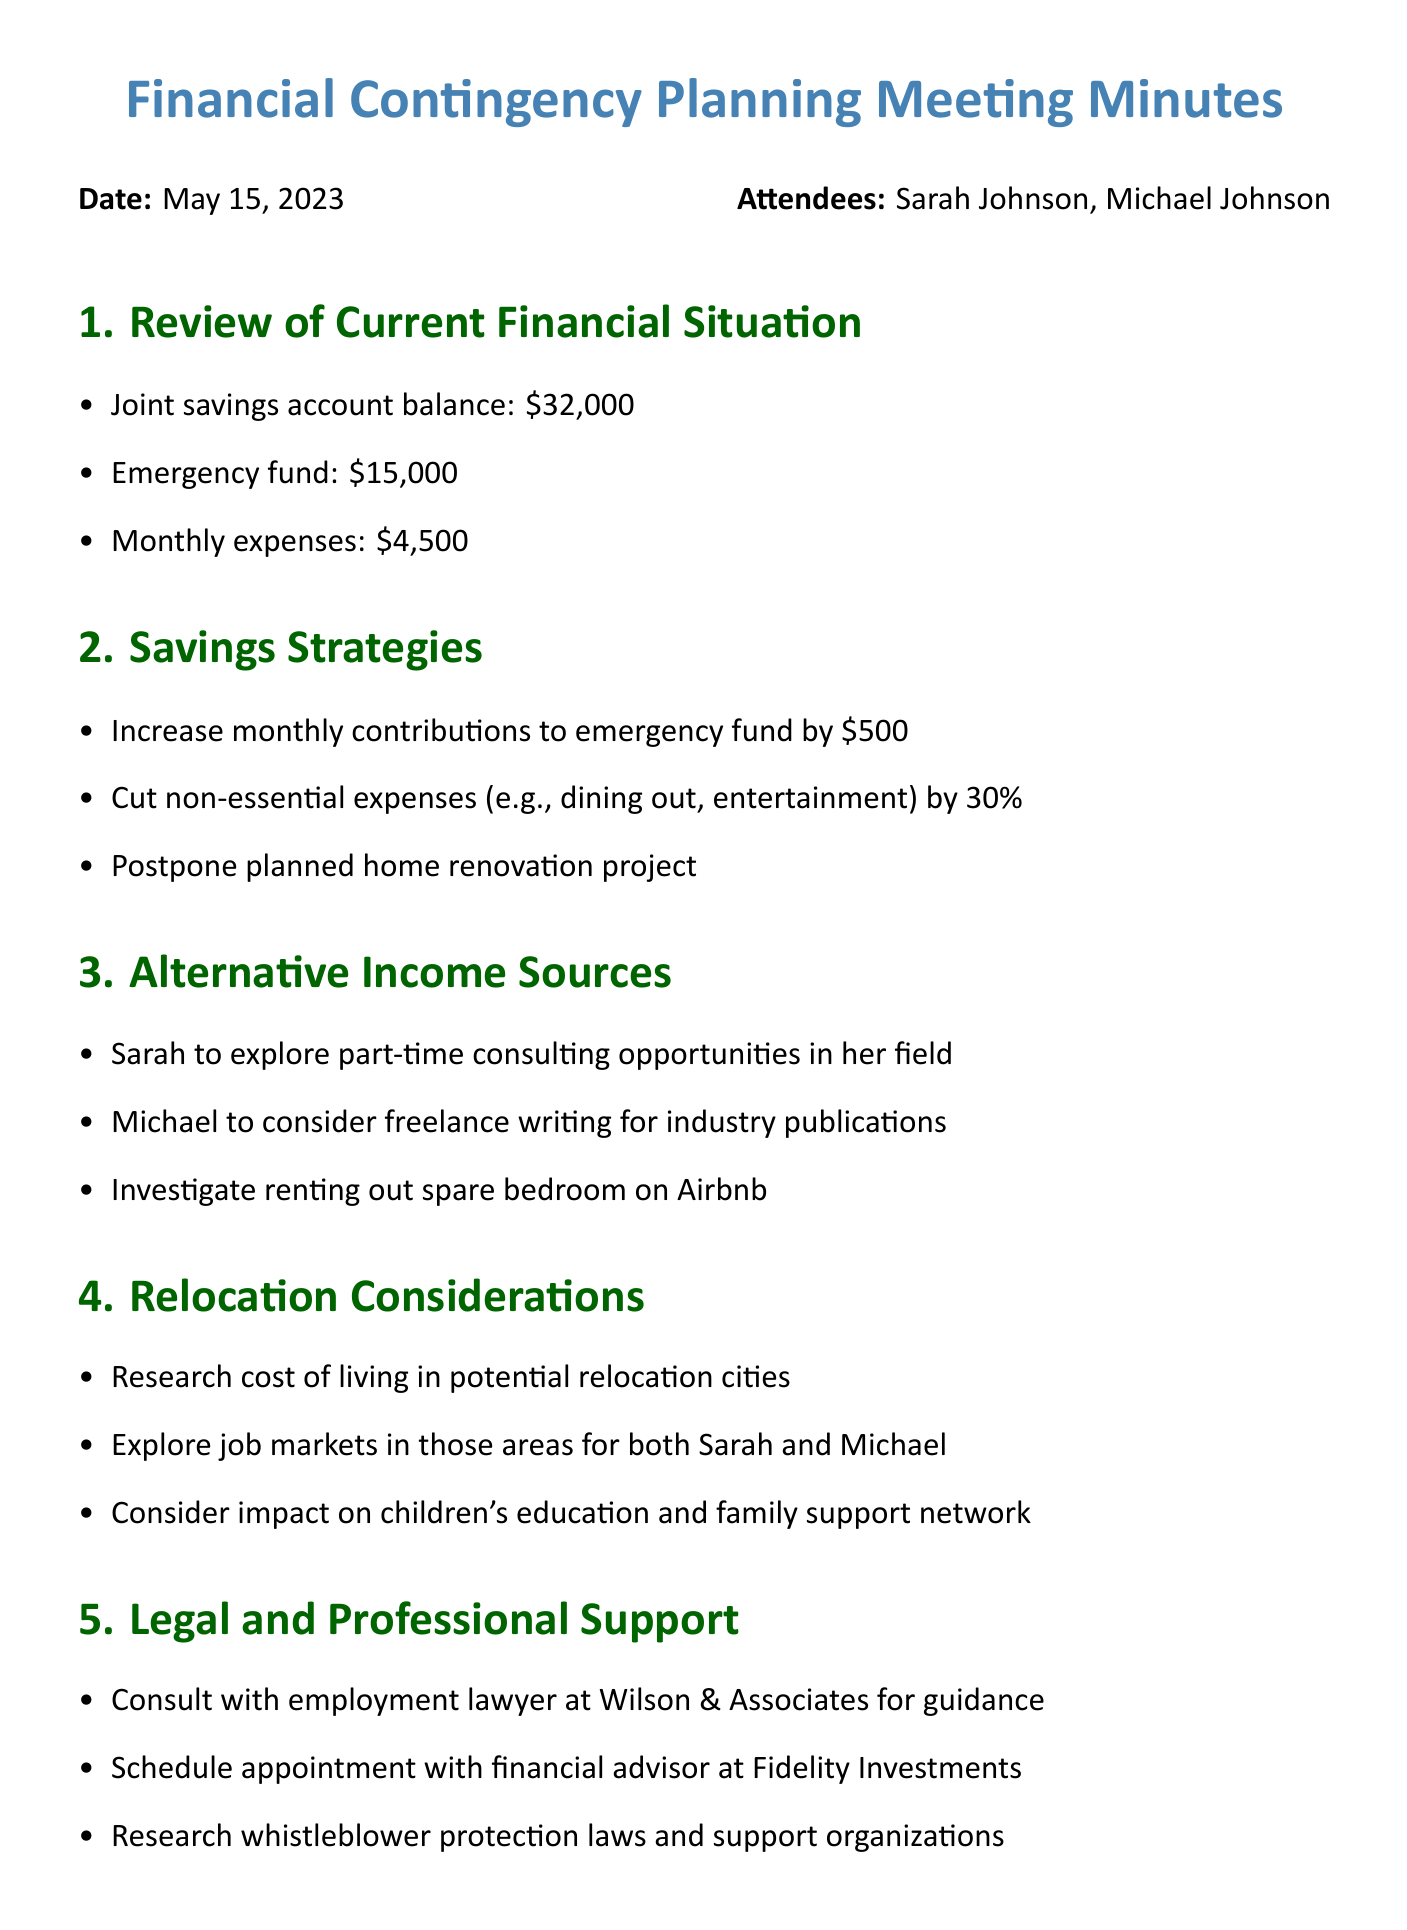What is the joint savings account balance? The joint savings account balance is specified in the document as one of the current financial situation details.
Answer: $32,000 What is the amount planned to be contributed monthly to the emergency fund? The strategy outlined in the meeting minutes specifies how much will be added to the emergency fund each month.
Answer: $500 Which legal professional will be consulted for guidance? The document names a specific law firm and professional consultation related to legal support.
Answer: Wilson & Associates What are the monthly expenses listed in the document? Monthly expenses are clearly mentioned as part of the current financial situation in the minutes.
Answer: $4,500 Which alternative income source is Sarah going to explore? The document specifically mentions Sarah's initiative regarding her professional field as an alternative income source.
Answer: Part-time consulting opportunities What significant expense is proposed to be postponed? The document lists a planned expenditure that will be delayed, emphasizing a strategic savings approach.
Answer: Home renovation project What is the follow-up meeting's timeframe to review progress? The action items include a specific timeline for the follow-up meeting after the discussed actions are taken.
Answer: Two weeks What is one relocation consideration mentioned in the document? The meeting minutes outline various aspects to be considered concerning potential relocation.
Answer: Cost of living 